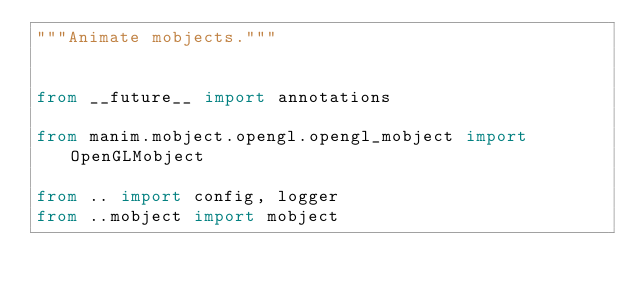Convert code to text. <code><loc_0><loc_0><loc_500><loc_500><_Python_>"""Animate mobjects."""


from __future__ import annotations

from manim.mobject.opengl.opengl_mobject import OpenGLMobject

from .. import config, logger
from ..mobject import mobject</code> 